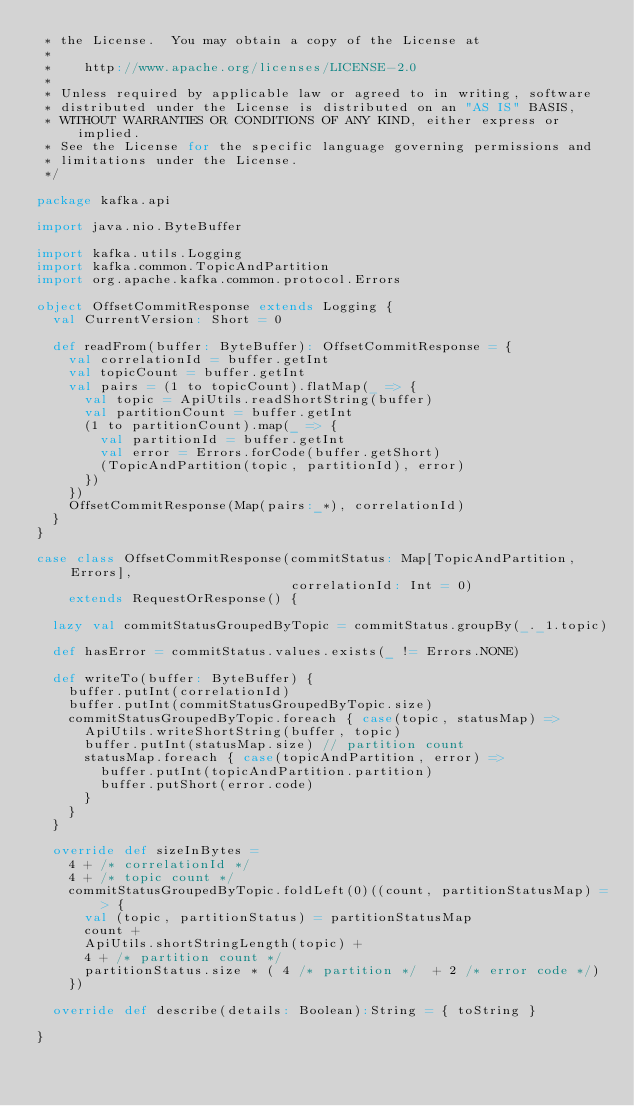<code> <loc_0><loc_0><loc_500><loc_500><_Scala_> * the License.  You may obtain a copy of the License at
 *
 *    http://www.apache.org/licenses/LICENSE-2.0
 *
 * Unless required by applicable law or agreed to in writing, software
 * distributed under the License is distributed on an "AS IS" BASIS,
 * WITHOUT WARRANTIES OR CONDITIONS OF ANY KIND, either express or implied.
 * See the License for the specific language governing permissions and
 * limitations under the License.
 */

package kafka.api

import java.nio.ByteBuffer

import kafka.utils.Logging
import kafka.common.TopicAndPartition
import org.apache.kafka.common.protocol.Errors

object OffsetCommitResponse extends Logging {
  val CurrentVersion: Short = 0

  def readFrom(buffer: ByteBuffer): OffsetCommitResponse = {
    val correlationId = buffer.getInt
    val topicCount = buffer.getInt
    val pairs = (1 to topicCount).flatMap(_ => {
      val topic = ApiUtils.readShortString(buffer)
      val partitionCount = buffer.getInt
      (1 to partitionCount).map(_ => {
        val partitionId = buffer.getInt
        val error = Errors.forCode(buffer.getShort)
        (TopicAndPartition(topic, partitionId), error)
      })
    })
    OffsetCommitResponse(Map(pairs:_*), correlationId)
  }
}

case class OffsetCommitResponse(commitStatus: Map[TopicAndPartition, Errors],
                                correlationId: Int = 0)
    extends RequestOrResponse() {

  lazy val commitStatusGroupedByTopic = commitStatus.groupBy(_._1.topic)

  def hasError = commitStatus.values.exists(_ != Errors.NONE)

  def writeTo(buffer: ByteBuffer) {
    buffer.putInt(correlationId)
    buffer.putInt(commitStatusGroupedByTopic.size)
    commitStatusGroupedByTopic.foreach { case(topic, statusMap) =>
      ApiUtils.writeShortString(buffer, topic)
      buffer.putInt(statusMap.size) // partition count
      statusMap.foreach { case(topicAndPartition, error) =>
        buffer.putInt(topicAndPartition.partition)
        buffer.putShort(error.code)
      }
    }
  }

  override def sizeInBytes =
    4 + /* correlationId */
    4 + /* topic count */
    commitStatusGroupedByTopic.foldLeft(0)((count, partitionStatusMap) => {
      val (topic, partitionStatus) = partitionStatusMap
      count +
      ApiUtils.shortStringLength(topic) +
      4 + /* partition count */
      partitionStatus.size * ( 4 /* partition */  + 2 /* error code */)
    })

  override def describe(details: Boolean):String = { toString }

}

</code> 